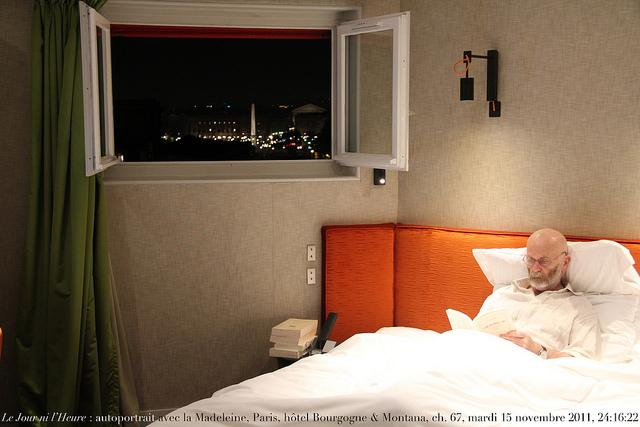Why does he need the light to be on?

Choices:
A) reading
B) writing
C) cooking
D) watching reading 